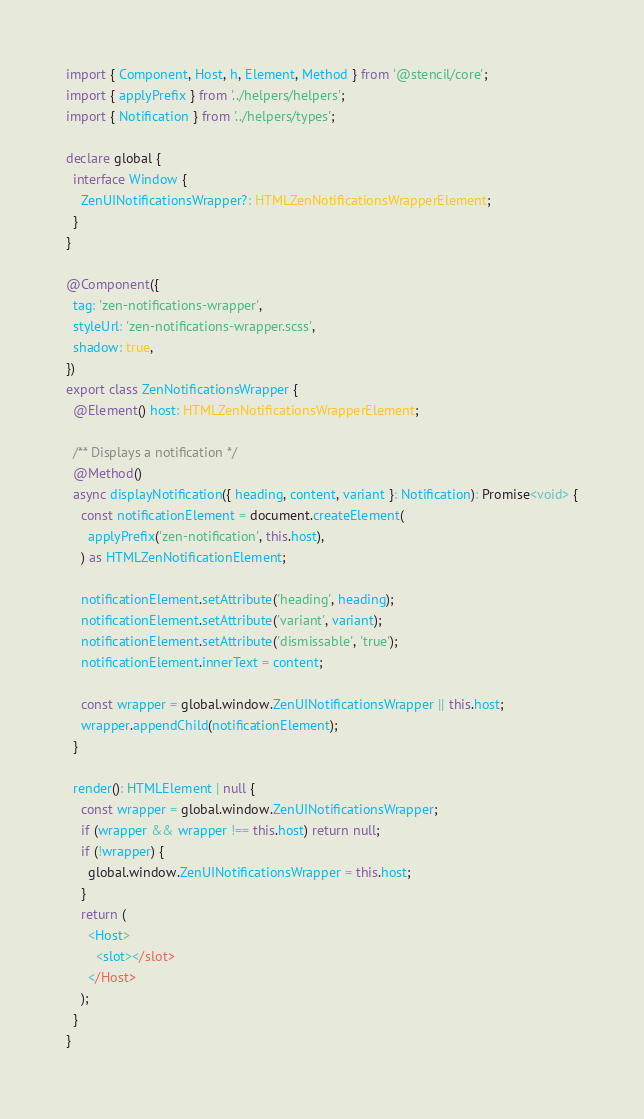Convert code to text. <code><loc_0><loc_0><loc_500><loc_500><_TypeScript_>import { Component, Host, h, Element, Method } from '@stencil/core';
import { applyPrefix } from '../helpers/helpers';
import { Notification } from '../helpers/types';

declare global {
  interface Window {
    ZenUINotificationsWrapper?: HTMLZenNotificationsWrapperElement;
  }
}

@Component({
  tag: 'zen-notifications-wrapper',
  styleUrl: 'zen-notifications-wrapper.scss',
  shadow: true,
})
export class ZenNotificationsWrapper {
  @Element() host: HTMLZenNotificationsWrapperElement;

  /** Displays a notification */
  @Method()
  async displayNotification({ heading, content, variant }: Notification): Promise<void> {
    const notificationElement = document.createElement(
      applyPrefix('zen-notification', this.host),
    ) as HTMLZenNotificationElement;

    notificationElement.setAttribute('heading', heading);
    notificationElement.setAttribute('variant', variant);
    notificationElement.setAttribute('dismissable', 'true');
    notificationElement.innerText = content;

    const wrapper = global.window.ZenUINotificationsWrapper || this.host;
    wrapper.appendChild(notificationElement);
  }

  render(): HTMLElement | null {
    const wrapper = global.window.ZenUINotificationsWrapper;
    if (wrapper && wrapper !== this.host) return null;
    if (!wrapper) {
      global.window.ZenUINotificationsWrapper = this.host;
    }
    return (
      <Host>
        <slot></slot>
      </Host>
    );
  }
}
</code> 